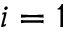<formula> <loc_0><loc_0><loc_500><loc_500>i = 1</formula> 